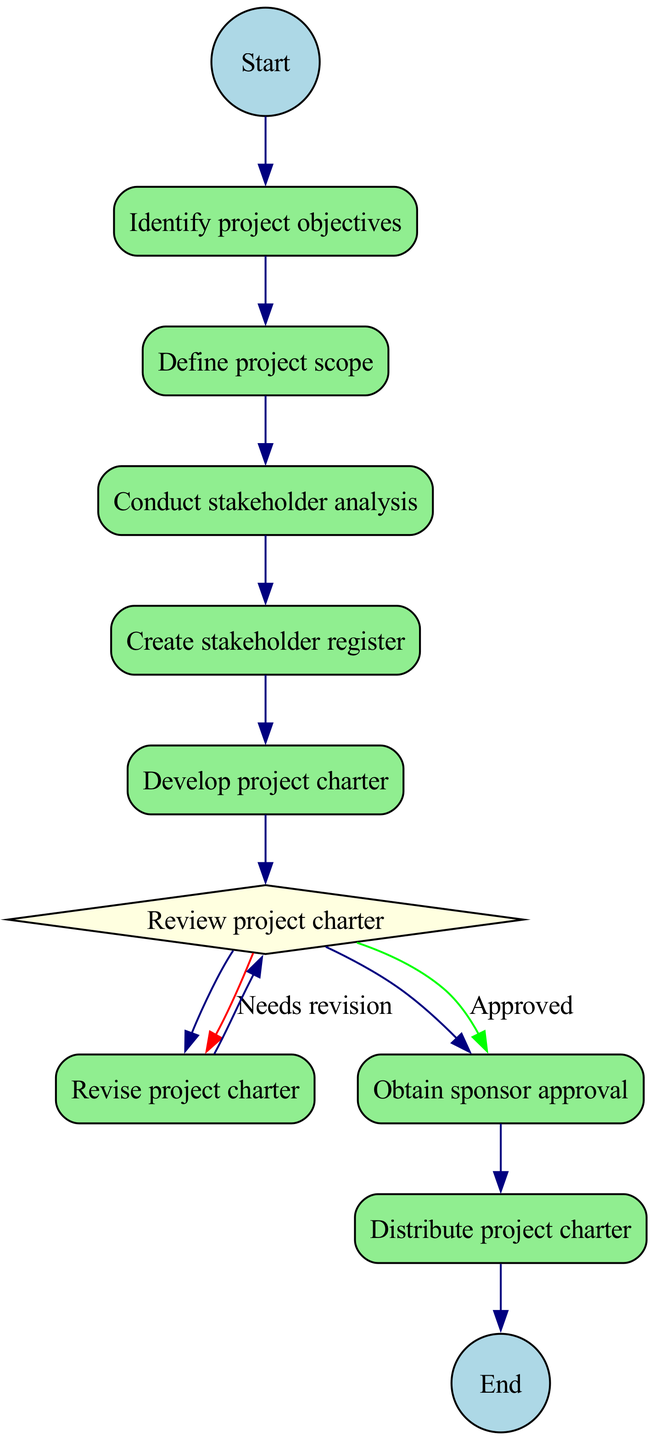What's the first node in the diagram? The diagram starts from the node labeled "Start", which indicates the beginning of the process.
Answer: Start How many nodes are there in total? The diagram contains 11 nodes, as listed in the provided data.
Answer: 11 What is the last node before the end in the process? The node prior to "End" is "Distribute project charter", which shows the last action taken before concluding the process.
Answer: Distribute project charter What action follows "Conduct stakeholder analysis"? The action that follows "Conduct stakeholder analysis" is "Create stakeholder register", which indicates the next step in the process.
Answer: Create stakeholder register What are the two possible outcomes after reviewing the project charter? The two outcomes after reviewing the project charter are "Approved" and "Needs revision", which dictate the next steps based on the review results.
Answer: Approved, Needs revision What is the shape of the decision node in this diagram? The decision node, which is "Review project charter", is represented by a diamond shape, a common depiction for decision points in activity diagrams.
Answer: Diamond If the project charter needs revision, what is the next action performed? If the project charter needs revision, the next action is "Revise project charter", indicating a loop back to improve the charter before re-reviewing it.
Answer: Revise project charter How many edges connect the "Develop project charter" node? The "Develop project charter" node has one outgoing edge leading to the "Review project charter" node, indicating the single action taken after development.
Answer: 1 After the project charter is approved, what is the subsequent step? Once the project charter is approved, the subsequent step is to "Obtain sponsor approval", which shows the approval chain in the project initiation process.
Answer: Obtain sponsor approval 